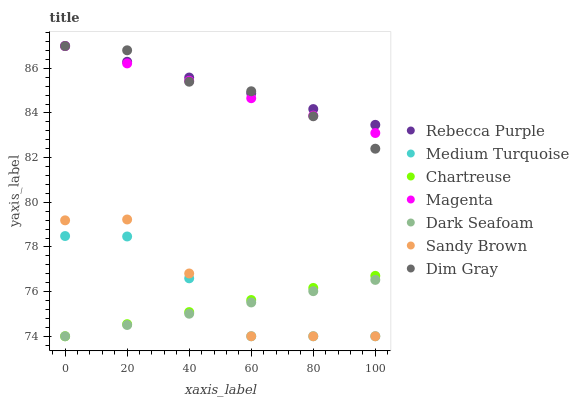Does Dark Seafoam have the minimum area under the curve?
Answer yes or no. Yes. Does Rebecca Purple have the maximum area under the curve?
Answer yes or no. Yes. Does Chartreuse have the minimum area under the curve?
Answer yes or no. No. Does Chartreuse have the maximum area under the curve?
Answer yes or no. No. Is Chartreuse the smoothest?
Answer yes or no. Yes. Is Sandy Brown the roughest?
Answer yes or no. Yes. Is Dark Seafoam the smoothest?
Answer yes or no. No. Is Dark Seafoam the roughest?
Answer yes or no. No. Does Chartreuse have the lowest value?
Answer yes or no. Yes. Does Rebecca Purple have the lowest value?
Answer yes or no. No. Does Magenta have the highest value?
Answer yes or no. Yes. Does Chartreuse have the highest value?
Answer yes or no. No. Is Sandy Brown less than Magenta?
Answer yes or no. Yes. Is Rebecca Purple greater than Medium Turquoise?
Answer yes or no. Yes. Does Medium Turquoise intersect Dark Seafoam?
Answer yes or no. Yes. Is Medium Turquoise less than Dark Seafoam?
Answer yes or no. No. Is Medium Turquoise greater than Dark Seafoam?
Answer yes or no. No. Does Sandy Brown intersect Magenta?
Answer yes or no. No. 